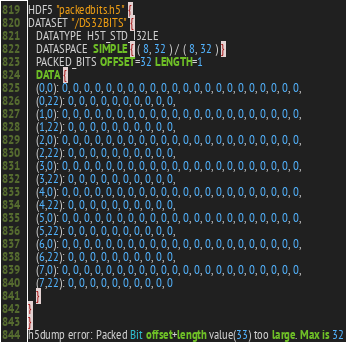Convert code to text. <code><loc_0><loc_0><loc_500><loc_500><_SQL_>HDF5 "packedbits.h5" {
DATASET "/DS32BITS" {
   DATATYPE  H5T_STD_I32LE
   DATASPACE  SIMPLE { ( 8, 32 ) / ( 8, 32 ) }
   PACKED_BITS OFFSET=32 LENGTH=1
   DATA {
   (0,0): 0, 0, 0, 0, 0, 0, 0, 0, 0, 0, 0, 0, 0, 0, 0, 0, 0, 0, 0, 0, 0, 0,
   (0,22): 0, 0, 0, 0, 0, 0, 0, 0, 0, 0,
   (1,0): 0, 0, 0, 0, 0, 0, 0, 0, 0, 0, 0, 0, 0, 0, 0, 0, 0, 0, 0, 0, 0, 0,
   (1,22): 0, 0, 0, 0, 0, 0, 0, 0, 0, 0,
   (2,0): 0, 0, 0, 0, 0, 0, 0, 0, 0, 0, 0, 0, 0, 0, 0, 0, 0, 0, 0, 0, 0, 0,
   (2,22): 0, 0, 0, 0, 0, 0, 0, 0, 0, 0,
   (3,0): 0, 0, 0, 0, 0, 0, 0, 0, 0, 0, 0, 0, 0, 0, 0, 0, 0, 0, 0, 0, 0, 0,
   (3,22): 0, 0, 0, 0, 0, 0, 0, 0, 0, 0,
   (4,0): 0, 0, 0, 0, 0, 0, 0, 0, 0, 0, 0, 0, 0, 0, 0, 0, 0, 0, 0, 0, 0, 0,
   (4,22): 0, 0, 0, 0, 0, 0, 0, 0, 0, 0,
   (5,0): 0, 0, 0, 0, 0, 0, 0, 0, 0, 0, 0, 0, 0, 0, 0, 0, 0, 0, 0, 0, 0, 0,
   (5,22): 0, 0, 0, 0, 0, 0, 0, 0, 0, 0,
   (6,0): 0, 0, 0, 0, 0, 0, 0, 0, 0, 0, 0, 0, 0, 0, 0, 0, 0, 0, 0, 0, 0, 0,
   (6,22): 0, 0, 0, 0, 0, 0, 0, 0, 0, 0,
   (7,0): 0, 0, 0, 0, 0, 0, 0, 0, 0, 0, 0, 0, 0, 0, 0, 0, 0, 0, 0, 0, 0, 0,
   (7,22): 0, 0, 0, 0, 0, 0, 0, 0, 0, 0
   }
}
}
h5dump error: Packed Bit offset+length value(33) too large. Max is 32
</code> 